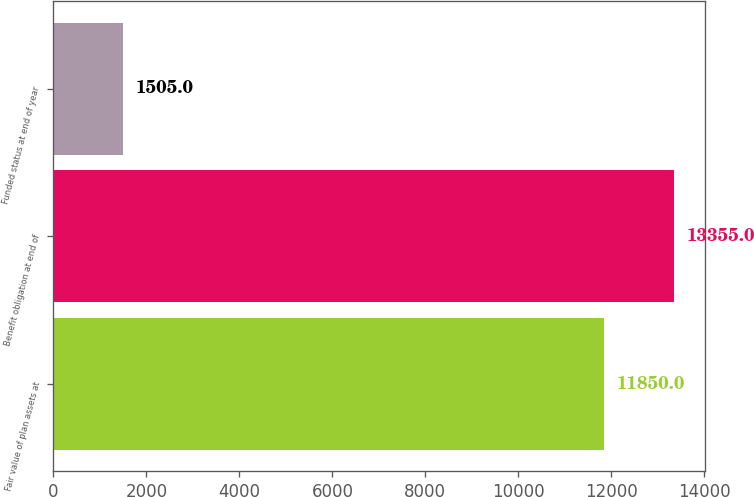<chart> <loc_0><loc_0><loc_500><loc_500><bar_chart><fcel>Fair value of plan assets at<fcel>Benefit obligation at end of<fcel>Funded status at end of year<nl><fcel>11850<fcel>13355<fcel>1505<nl></chart> 